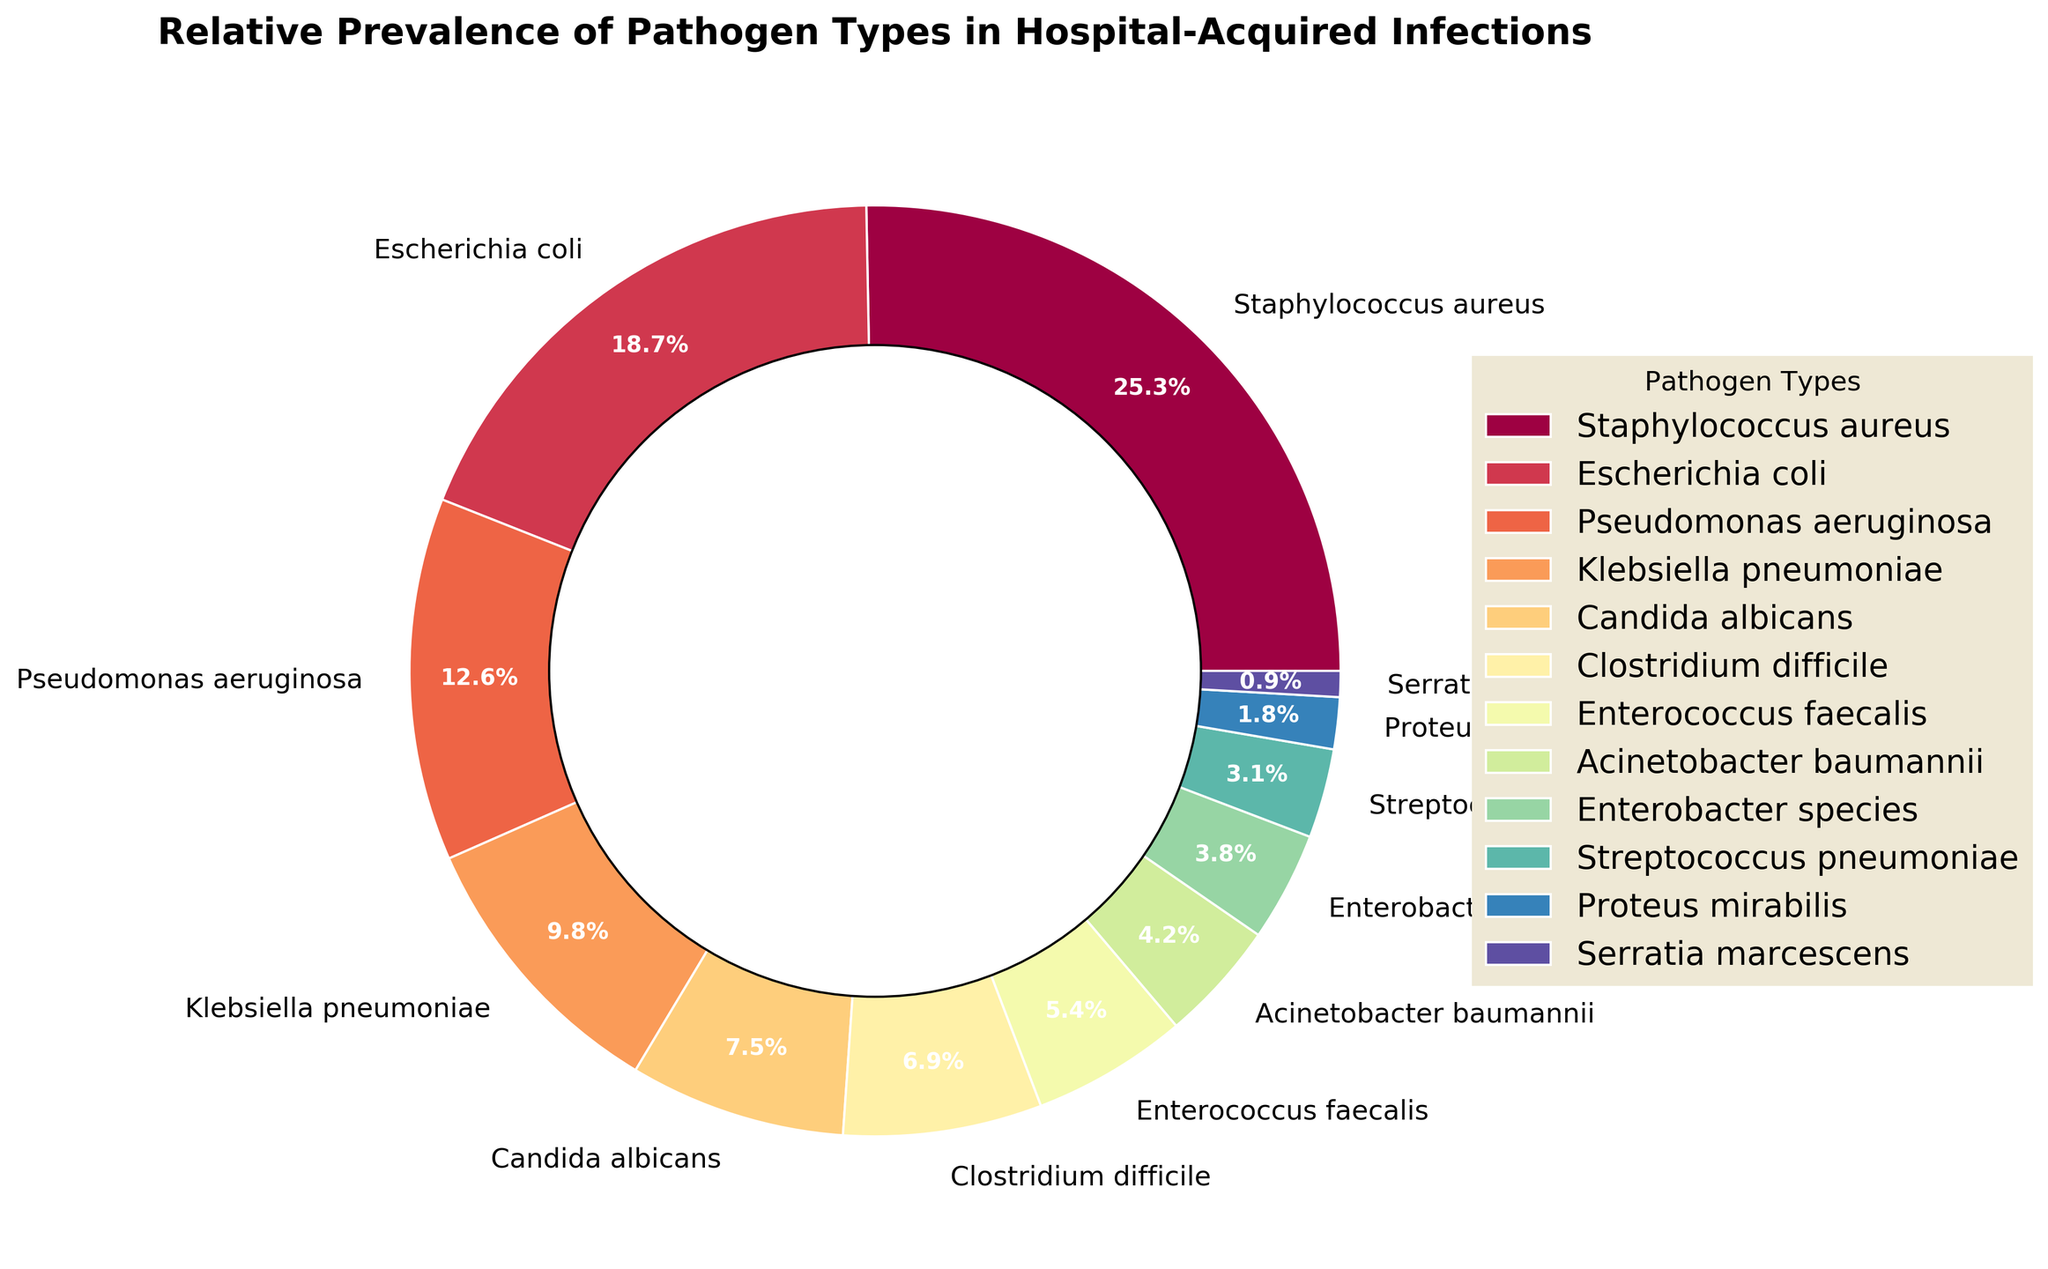What is the total percentage of infections caused by Escherichia coli and Pseudomonas aeruginosa combined? Add the percentages of Escherichia coli (18.7%) and Pseudomonas aeruginosa (12.6%). 18.7 + 12.6 = 31.3
Answer: 31.3 Which pathogen has the highest prevalence percentage? Identify the pathogen with the largest percentage in the pie chart, which is Staphylococcus aureus with 25.3%.
Answer: Staphylococcus aureus How does the prevalence of Klebsiella pneumoniae compare to that of Candida albicans? Compare the percentages listed for Klebsiella pneumoniae (9.8%) and Candida albicans (7.5%). 9.8 is greater than 7.5.
Answer: Klebsiella pneumoniae has a higher prevalence than Candida albicans What is the visual indicator (e.g., color) for Enterococcus faecalis in the pie chart? Look at the segment labeled Enterococcus faecalis in the pie chart and describe its color. The segment is represented with a specific color from the custom color palette used.
Answer: [The specific color displayed in the chart] What is the combined prevalence percentage of Enterococcus faecalis and Acinetobacter baumannii? Add the percentages of Enterococcus faecalis (5.4%) and Acinetobacter baumannii (4.2%). 5.4 + 4.2 = 9.6
Answer: 9.6 Which two pathogens collectively account for approximately one-third of the infections? Look for two pathogens whose combined percentage is close to 33.3%. Staphylococcus aureus (25.3%) and Pseudomonas aeruginosa (12.6%) sum to 37.9%, whereas Escherichia coli (18.7%) and Pseudomonas aeruginosa (12.6%) sum to 31.3%. The latter pair is closer to one-third.
Answer: Escherichia coli and Pseudomonas aeruginosa Is there any pathogen type that has a prevalence percentage less than 1%? Examine the pathogens listed and find any whose percentage is below 1%. Serratia marcescens is 0.9%.
Answer: Yes, Serratia marcescens Which pathogens have a lower prevalence than Klebsiella pneumoniae but higher than Clostridium difficile? Compare the percentages of pathogens and identify those falling between Klebsiella pneumoniae (9.8%) and Clostridium difficile (6.9%). Candida albicans fits this criterion with 7.5%.
Answer: Candida albicans 